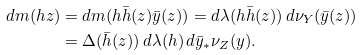Convert formula to latex. <formula><loc_0><loc_0><loc_500><loc_500>d m ( h z ) & = d m ( h \bar { h } ( z ) \bar { y } ( z ) ) = d \lambda ( h \bar { h } ( z ) ) \, d \nu _ { Y } ( \bar { y } ( z ) ) \\ & = \Delta ( \bar { h } ( z ) ) \, d \lambda ( h ) \, d \bar { y } _ { * } \nu _ { Z } ( y ) .</formula> 